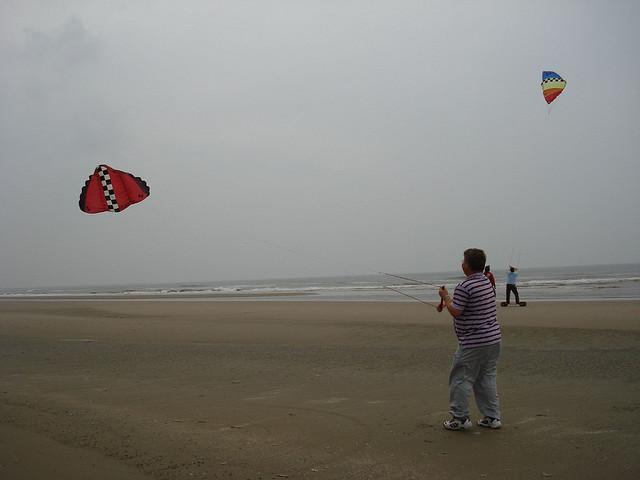How many kites have a checkered pattern?
Give a very brief answer. 2. How many kites are there?
Give a very brief answer. 2. How many people are holding onto the parachute line?
Give a very brief answer. 1. 